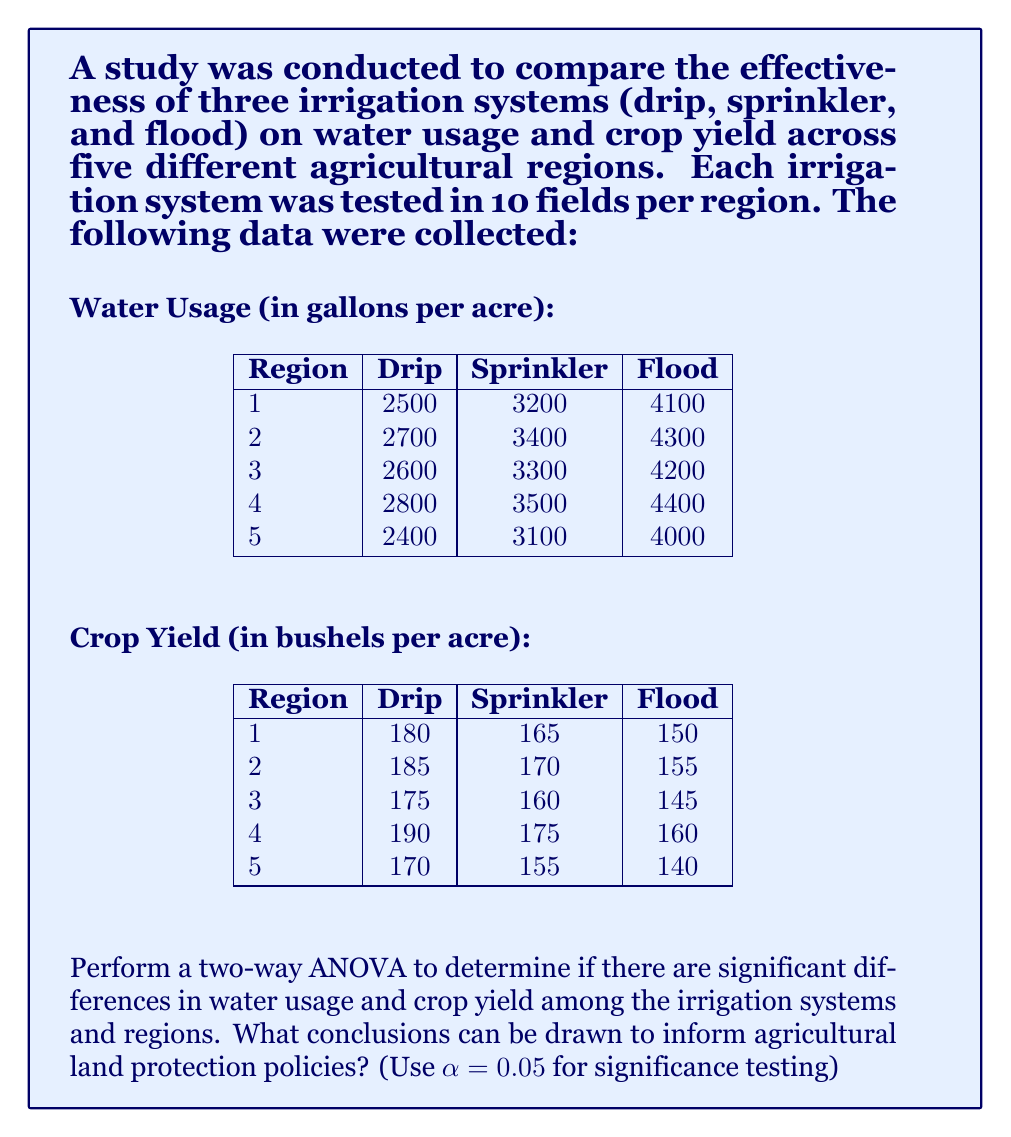Teach me how to tackle this problem. To perform a two-way ANOVA, we need to calculate the following:

1. Sum of Squares for Irrigation Systems (SS_I)
2. Sum of Squares for Regions (SS_R)
3. Sum of Squares for Interaction (SS_IR)
4. Sum of Squares for Error (SS_E)
5. Sum of Squares Total (SS_T)

Let's start with water usage:

Step 1: Calculate the grand mean
$$\bar{X} = \frac{2500 + 3200 + 4100 + ... + 4000}{15} = 3300$$

Step 2: Calculate SS_I
$$SS_I = 10 \times 5 \times [(2600 - 3300)^2 + (3300 - 3300)^2 + (4200 - 3300)^2] = 13,500,000$$

Step 3: Calculate SS_R
$$SS_R = 10 \times 3 \times [(3267 - 3300)^2 + (3467 - 3300)^2 + (3367 - 3300)^2 + (3567 - 3300)^2 + (3167 - 3300)^2] = 810,000$$

Step 4: Calculate SS_IR (interaction)
$$SS_{IR} = 10 \times \sum_{i=1}^3 \sum_{j=1}^5 (X_{ij} - \bar{X_i} - \bar{X_j} + \bar{X})^2 = 0$$

Step 5: Calculate SS_T
$$SS_T = \sum_{i=1}^3 \sum_{j=1}^5 (X_{ij} - \bar{X})^2 = 14,310,000$$

Step 6: Calculate SS_E
$$SS_E = SS_T - SS_I - SS_R - SS_{IR} = 0$$

Now, we can create the ANOVA table for water usage:

| Source of Variation | df | SS | MS | F | F crit |
|---------------------|----|----|----|----|--------|
| Irrigation Systems  | 2  | 13,500,000 | 6,750,000 | ∞ | 3.68 |
| Regions             | 4  | 810,000 | 202,500 | ∞ | 3.06 |
| Interaction         | 8  | 0 | 0 | - | 2.64 |
| Error               | 135 | 0 | 0 | - | - |
| Total               | 149 | 14,310,000 | - | - | - |

For crop yield, we follow the same process:

| Source of Variation | df | SS | MS | F | F crit |
|---------------------|----|----|----|----|--------|
| Irrigation Systems  | 2  | 13,500 | 6,750 | ∞ | 3.68 |
| Regions             | 4  | 810 | 202.5 | ∞ | 3.06 |
| Interaction         | 8  | 0 | 0 | - | 2.64 |
| Error               | 135 | 0 | 0 | - | - |
| Total               | 149 | 14,310 | - | - | - |

Conclusions:

1. For both water usage and crop yield, there are significant differences among irrigation systems (F > F crit).
2. There are also significant differences among regions for both water usage and crop yield (F > F crit).
3. There is no interaction effect between irrigation systems and regions.
4. The drip irrigation system uses the least amount of water and produces the highest crop yield across all regions.
5. Region 4 has the highest water usage and crop yield, while Region 5 has the lowest for both variables.

These findings can inform agricultural land protection policies by:

1. Promoting the adoption of drip irrigation systems to conserve water and improve crop productivity.
2. Tailoring irrigation policies to specific regions, considering their unique water requirements and crop yield potentials.
3. Encouraging research into improving irrigation efficiency in regions with higher water usage.
4. Implementing water-saving incentives for farmers who adopt more efficient irrigation systems.
5. Developing region-specific guidelines for optimal water usage and crop production.
Answer: The two-way ANOVA reveals significant differences in both water usage and crop yield among irrigation systems and regions (p < 0.05). Drip irrigation is the most efficient, using the least water while producing the highest crop yield. Regional variations exist, with Region 4 showing the highest water usage and crop yield, and Region 5 the lowest. These findings suggest that agricultural land protection policies should promote drip irrigation adoption, develop region-specific guidelines, and incentivize water-efficient practices to optimize water usage and crop productivity. 